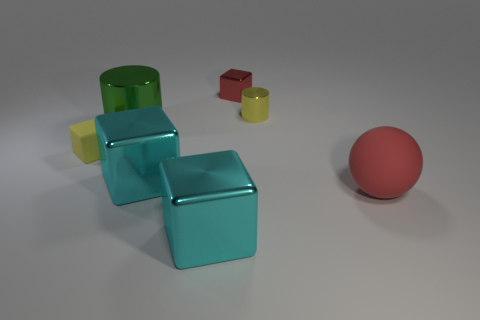Subtract 2 cubes. How many cubes are left? 2 Add 2 red blocks. How many objects exist? 9 Subtract all metal blocks. How many blocks are left? 1 Subtract all cyan cubes. How many cubes are left? 2 Subtract all cyan cubes. How many blue cylinders are left? 0 Subtract 0 gray balls. How many objects are left? 7 Subtract all blocks. How many objects are left? 3 Subtract all purple balls. Subtract all cyan blocks. How many balls are left? 1 Subtract all tiny blue cylinders. Subtract all yellow shiny things. How many objects are left? 6 Add 4 large red rubber balls. How many large red rubber balls are left? 5 